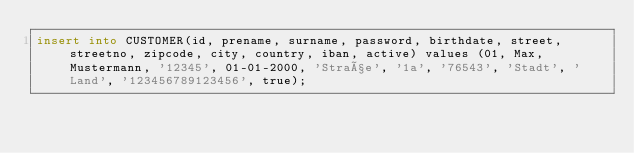Convert code to text. <code><loc_0><loc_0><loc_500><loc_500><_SQL_>insert into CUSTOMER(id, prename, surname, password, birthdate, street, streetno, zipcode, city, country, iban, active) values (01, Max, Mustermann, '12345', 01-01-2000, 'Straße', '1a', '76543', 'Stadt', 'Land', '123456789123456', true);</code> 